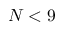<formula> <loc_0><loc_0><loc_500><loc_500>N < 9</formula> 